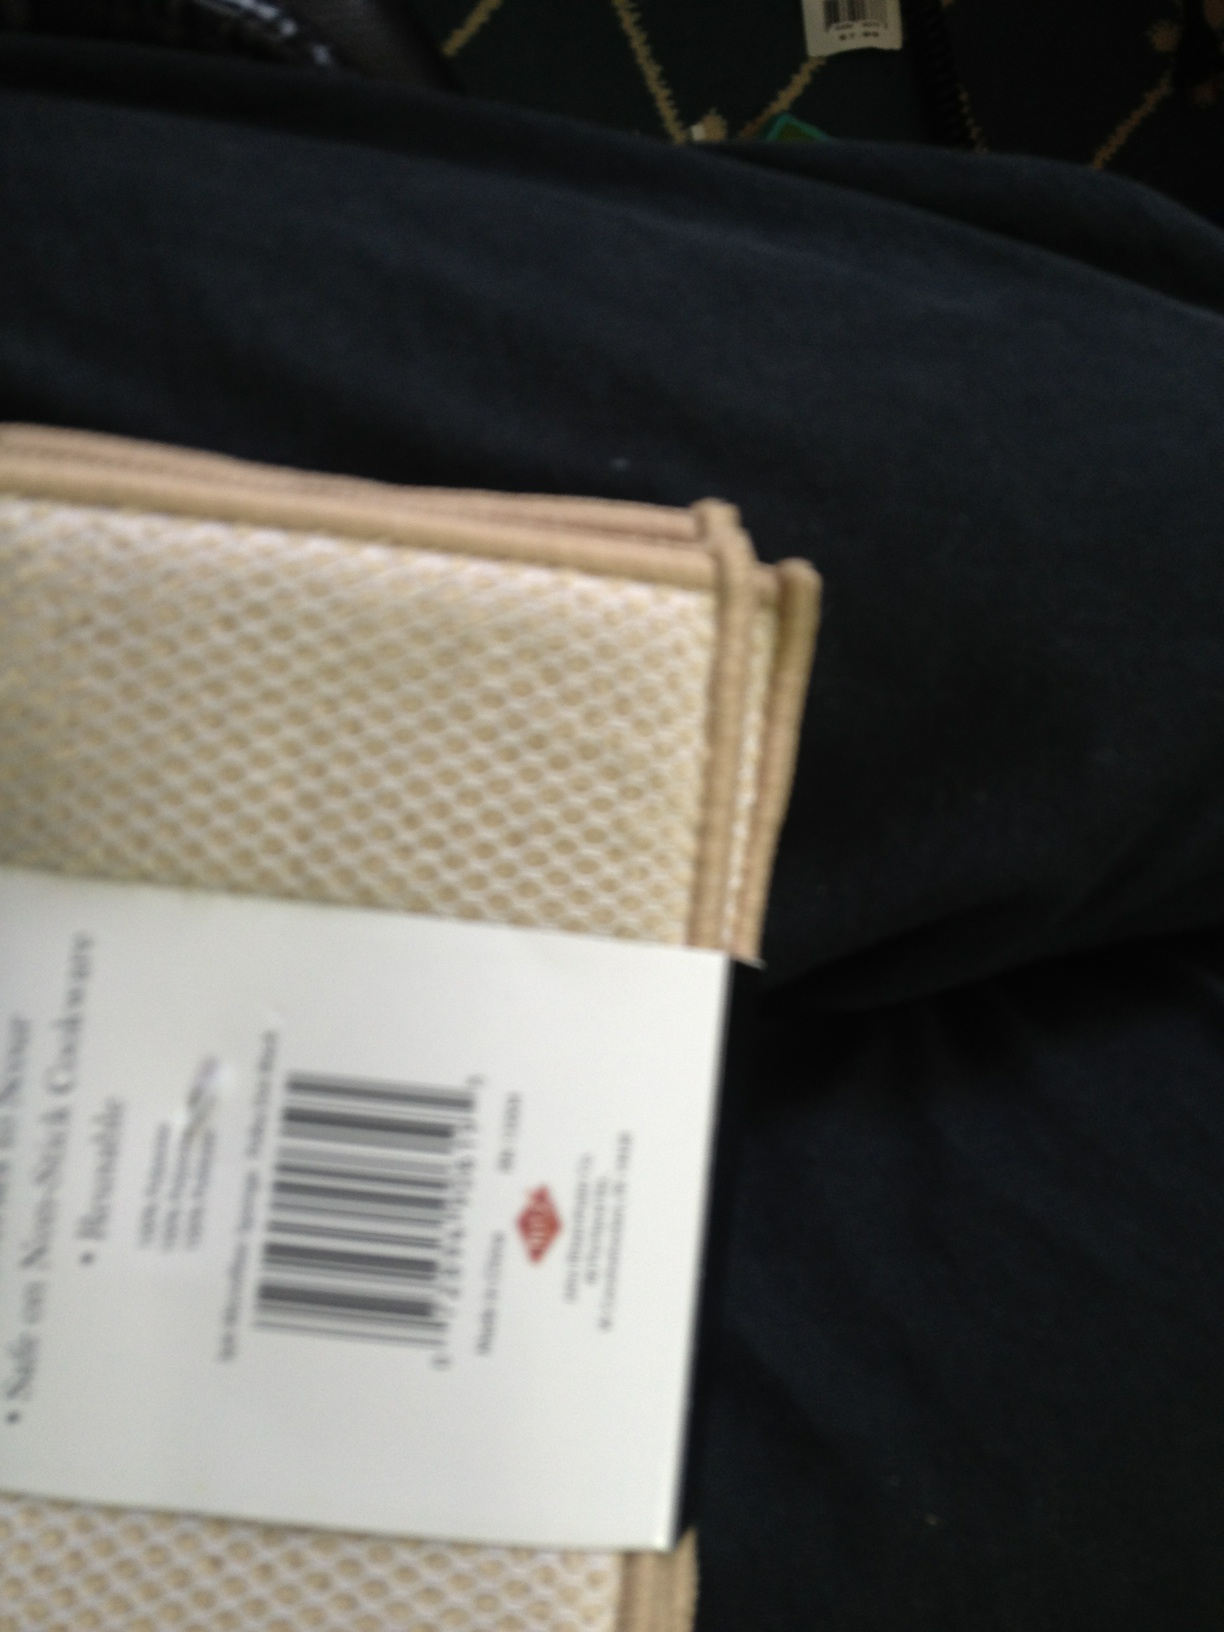What can you infer about the setting of this photo? While the photo is blurry, the context suggests a personal setting. The combination of clothing and the background pattern indicates someone likely sitting down, perhaps inside a vehicle given the design of the seats or on a patterned couch. The barcode visible might imply that the person has recently made a purchase, or it's an item they have with them. 